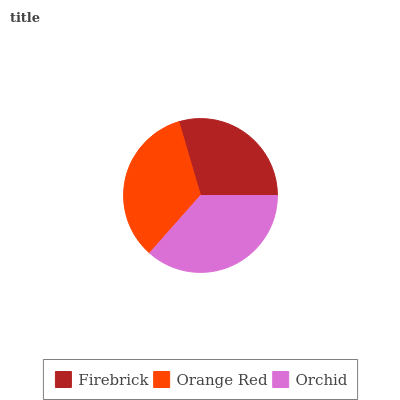Is Firebrick the minimum?
Answer yes or no. Yes. Is Orchid the maximum?
Answer yes or no. Yes. Is Orange Red the minimum?
Answer yes or no. No. Is Orange Red the maximum?
Answer yes or no. No. Is Orange Red greater than Firebrick?
Answer yes or no. Yes. Is Firebrick less than Orange Red?
Answer yes or no. Yes. Is Firebrick greater than Orange Red?
Answer yes or no. No. Is Orange Red less than Firebrick?
Answer yes or no. No. Is Orange Red the high median?
Answer yes or no. Yes. Is Orange Red the low median?
Answer yes or no. Yes. Is Firebrick the high median?
Answer yes or no. No. Is Firebrick the low median?
Answer yes or no. No. 